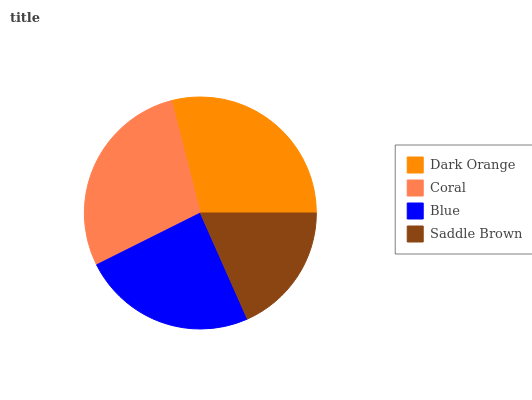Is Saddle Brown the minimum?
Answer yes or no. Yes. Is Dark Orange the maximum?
Answer yes or no. Yes. Is Coral the minimum?
Answer yes or no. No. Is Coral the maximum?
Answer yes or no. No. Is Dark Orange greater than Coral?
Answer yes or no. Yes. Is Coral less than Dark Orange?
Answer yes or no. Yes. Is Coral greater than Dark Orange?
Answer yes or no. No. Is Dark Orange less than Coral?
Answer yes or no. No. Is Coral the high median?
Answer yes or no. Yes. Is Blue the low median?
Answer yes or no. Yes. Is Saddle Brown the high median?
Answer yes or no. No. Is Coral the low median?
Answer yes or no. No. 